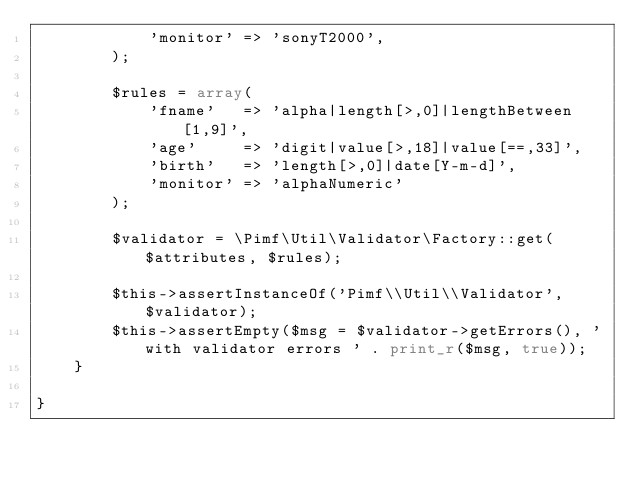<code> <loc_0><loc_0><loc_500><loc_500><_PHP_>            'monitor' => 'sonyT2000',
        );

        $rules = array(
            'fname'   => 'alpha|length[>,0]|lengthBetween[1,9]',
            'age'     => 'digit|value[>,18]|value[==,33]',
            'birth'   => 'length[>,0]|date[Y-m-d]',
            'monitor' => 'alphaNumeric'
        );

        $validator = \Pimf\Util\Validator\Factory::get($attributes, $rules);

        $this->assertInstanceOf('Pimf\\Util\\Validator', $validator);
        $this->assertEmpty($msg = $validator->getErrors(), 'with validator errors ' . print_r($msg, true));
    }

}
 </code> 